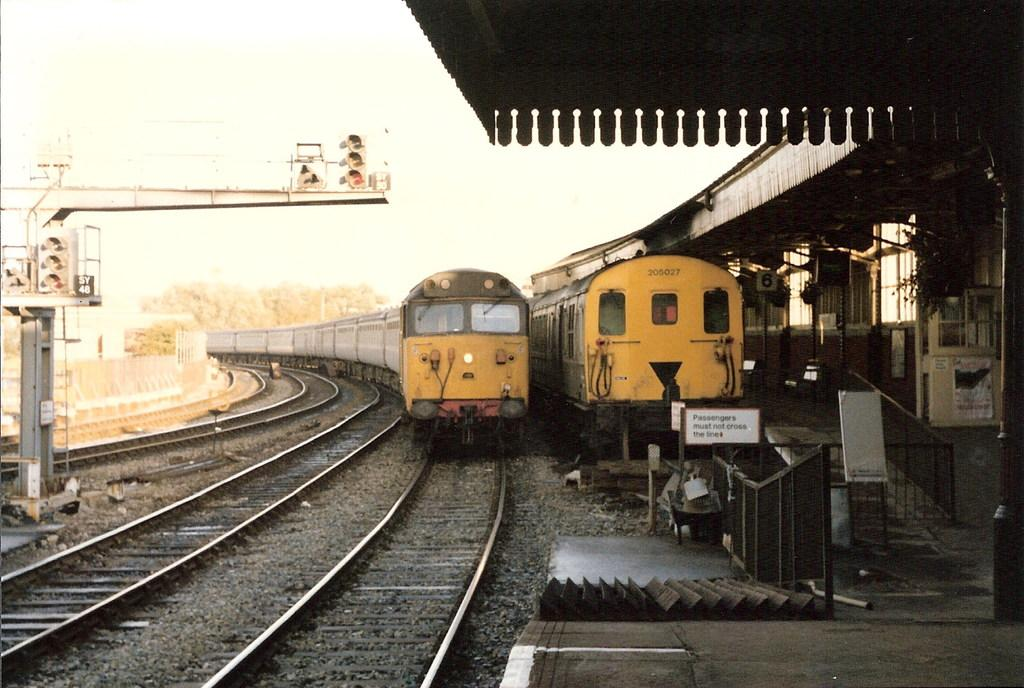What can be seen traveling on the train tracks in the image? There are trains on the train tracks in the image. What type of transportation infrastructure is present in the image? There is a train station in the image. What is the purpose of the fence in the image? The fence is present in the image, but its purpose cannot be determined from the provided facts. What type of vegetation is visible in the image? There are trees in the image. What part of the natural environment is visible in the image? The sky is visible in the image. Can you see the thumb of the person who took the picture in the image? There is no thumb visible in the image, as it is a photograph of trains, a train station, a fence, trees, and the sky. What type of pail is being used by the mother in the image? There is no mother or pail present in the image. 